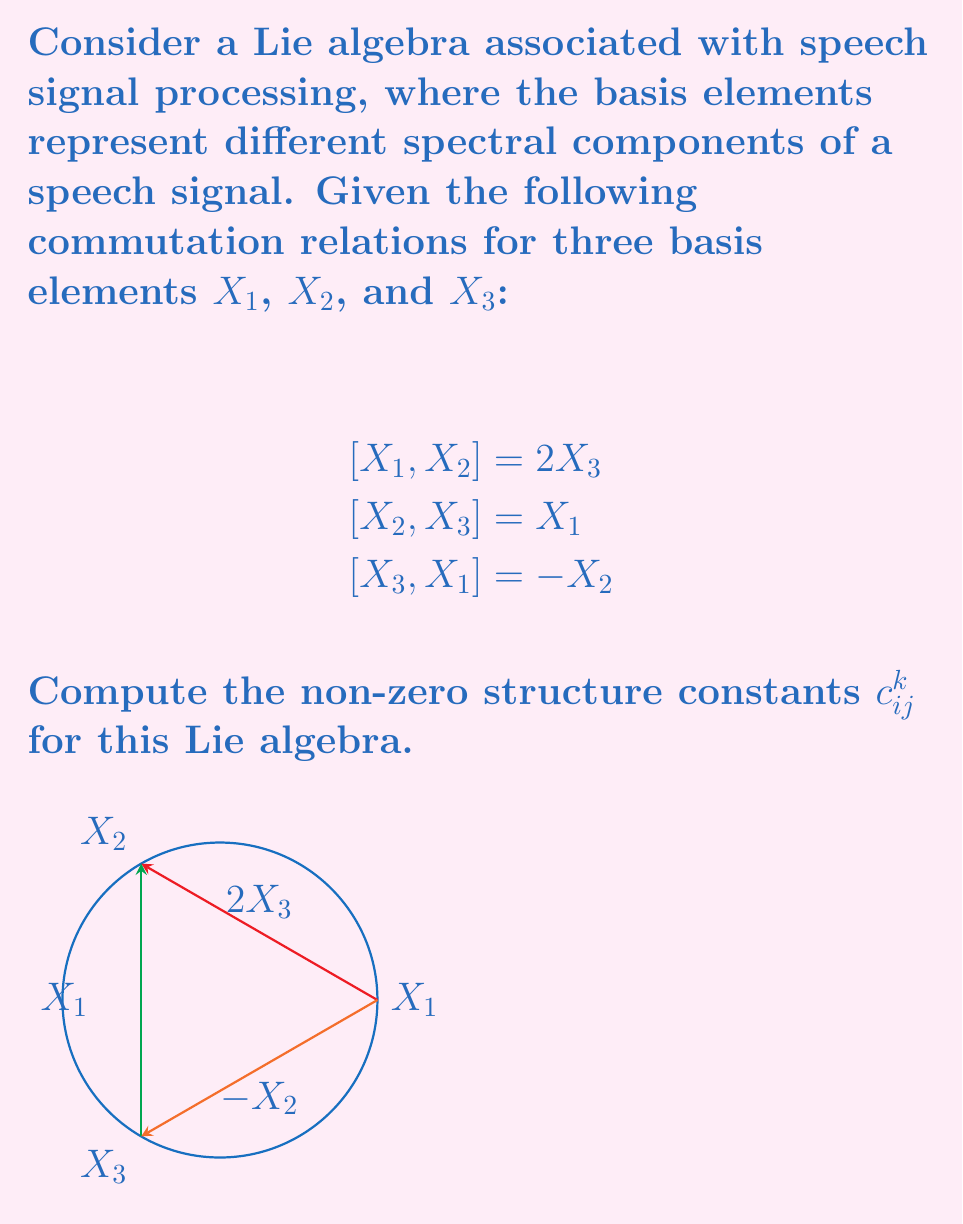Could you help me with this problem? To compute the structure constants of a Lie algebra, we need to express the commutators in terms of the structure constants:

$$[X_i, X_j] = \sum_k c_{ij}^k X_k$$

where $c_{ij}^k$ are the structure constants.

Let's analyze each commutation relation:

1) $[X_1, X_2] = 2X_3$
   This implies $c_{12}^3 = 2$ and $c_{12}^1 = c_{12}^2 = 0$

2) $[X_2, X_3] = X_1$
   This implies $c_{23}^1 = 1$ and $c_{23}^2 = c_{23}^3 = 0$

3) $[X_3, X_1] = -X_2$
   This implies $c_{31}^2 = -1$ and $c_{31}^1 = c_{31}^3 = 0$

Note that the structure constants are antisymmetric in the lower indices:
$$c_{ij}^k = -c_{ji}^k$$

Therefore, we can also deduce:
$c_{21}^3 = -2$
$c_{32}^1 = -1$
$c_{13}^2 = 1$

All other structure constants are zero.
Answer: $c_{12}^3 = 2$, $c_{23}^1 = 1$, $c_{31}^2 = -1$, $c_{21}^3 = -2$, $c_{32}^1 = -1$, $c_{13}^2 = 1$ 